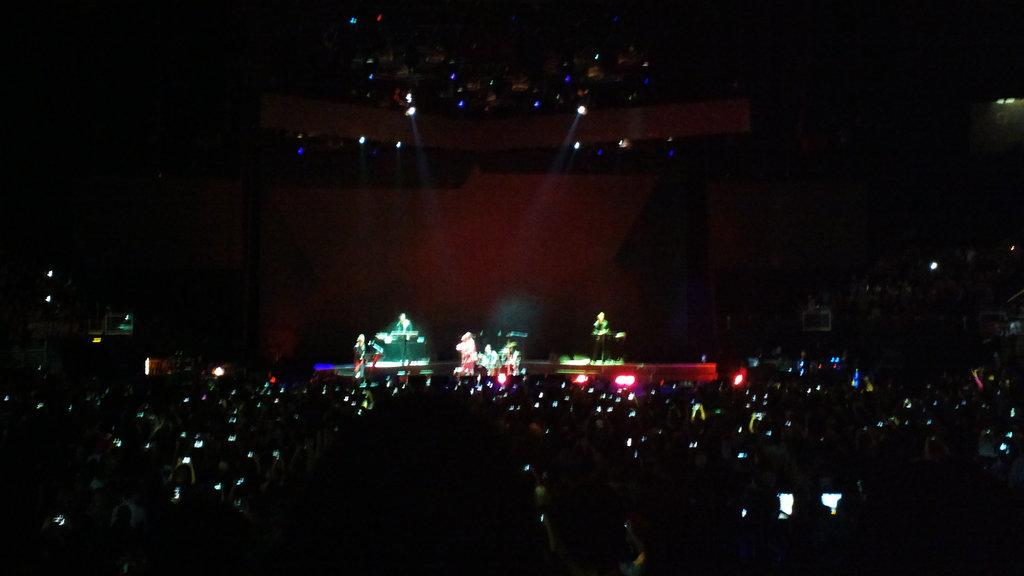What are the people at the bottom of the image doing? The people at the bottom of the image are holding phones. What can be seen in the background of the image? There are people with some objects in the background of the image. What is located at the top of the image? There are lights on the roof at the top of the image. Can you describe the destruction caused by the girl in the image? There is no girl or destruction present in the image. What is the time of day depicted in the image? The provided facts do not mention the time of day, so it cannot be determined from the image. 